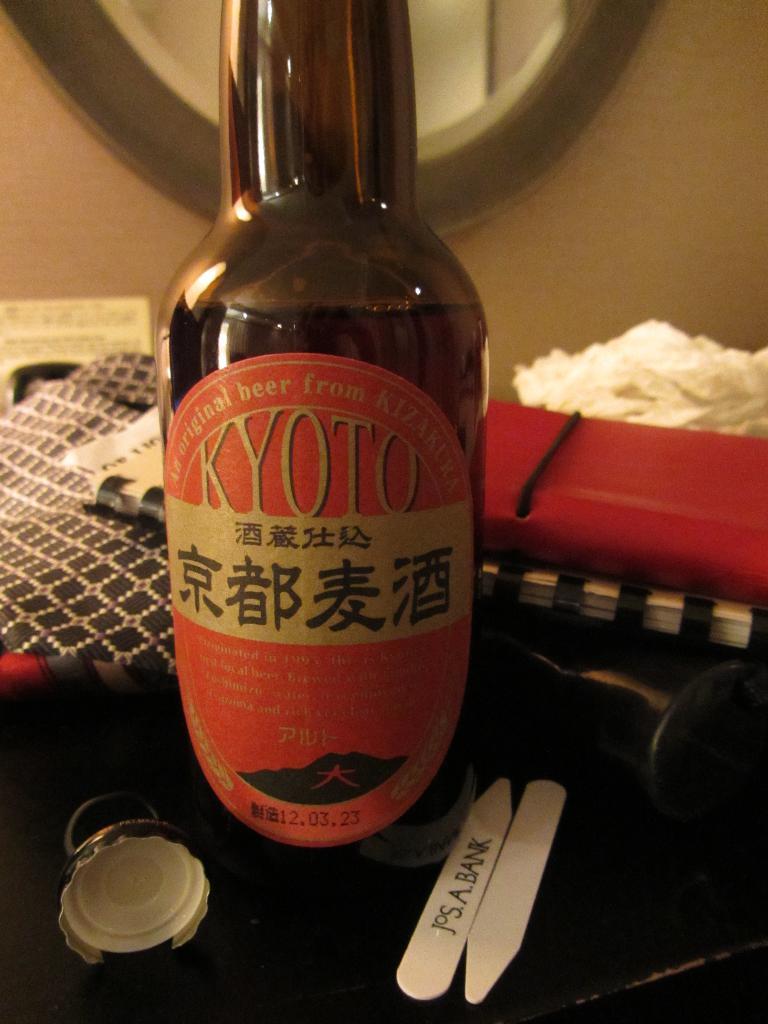What is the japanese beverage called?
Keep it short and to the point. Kyoto. What kind of drink is this?
Make the answer very short. Beer. 